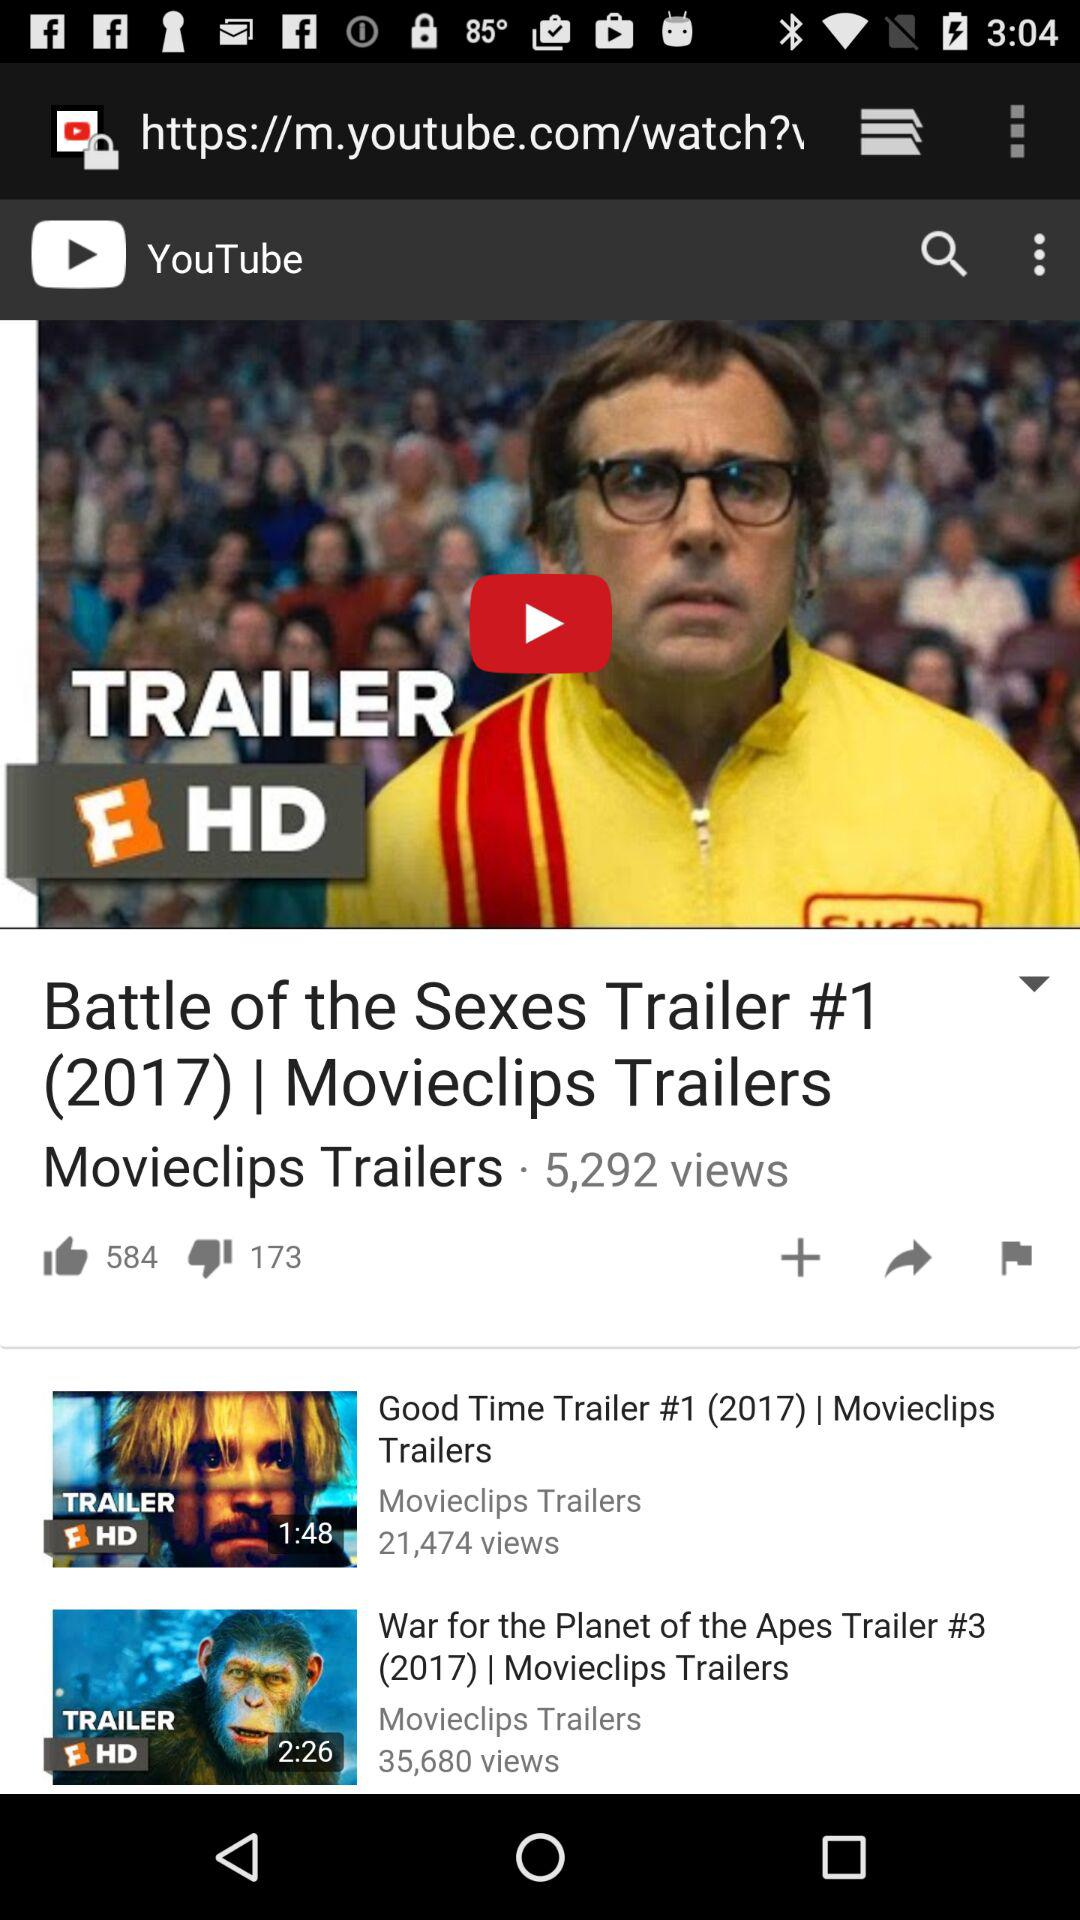Which video has 35,680 views? The video "War for the Planet of the Apes Trailer #3 (2017)" has 35,680 views. 